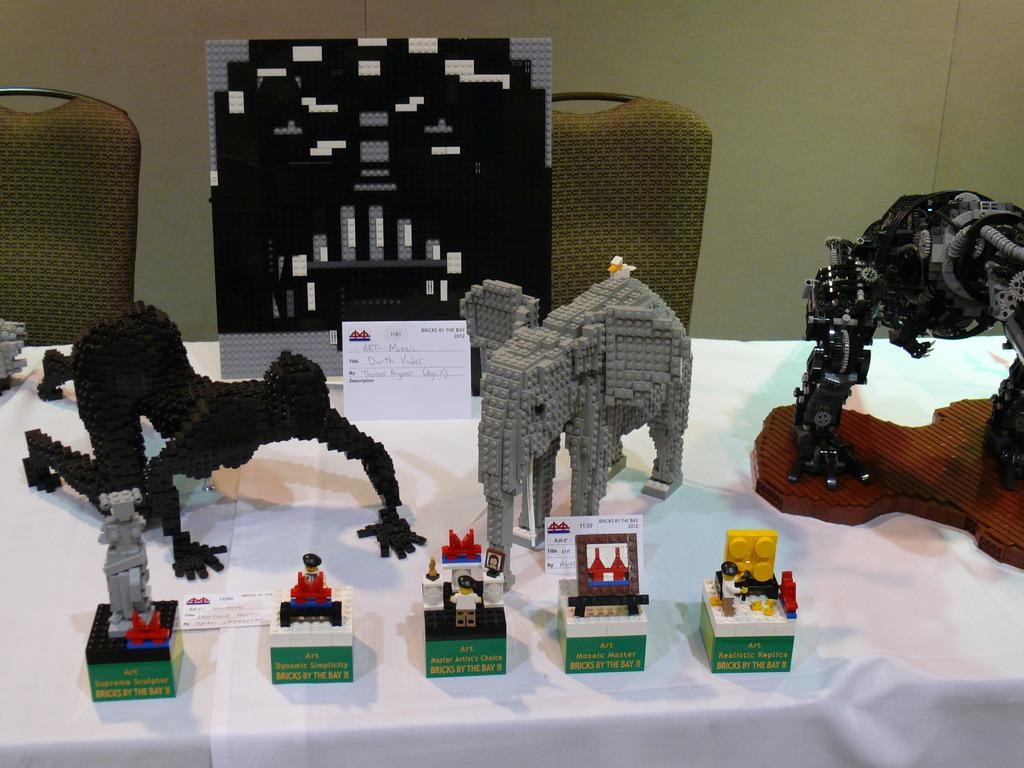What type of statues are present in the image? There is a block statue of a human and a block statue of an animal in the image. Where are the statues located? Both statues are on a table in the image. What else can be seen on the table? There are other block items on the table. What is the seating arrangement in the image? Chairs are present behind the table, on the floor. What unit of measurement is used to determine the size of the animal statue's heart in the image? There is no mention of a heart or any measurement unit in the image, as it features block statues of a human and an animal on a table with other block items. 